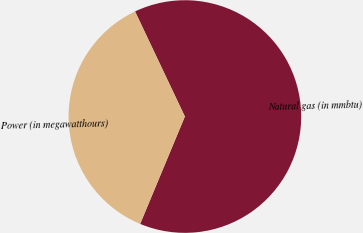<chart> <loc_0><loc_0><loc_500><loc_500><pie_chart><fcel>Natural gas (in mmbtu)<fcel>Power (in megawatthours)<nl><fcel>63.33%<fcel>36.67%<nl></chart> 